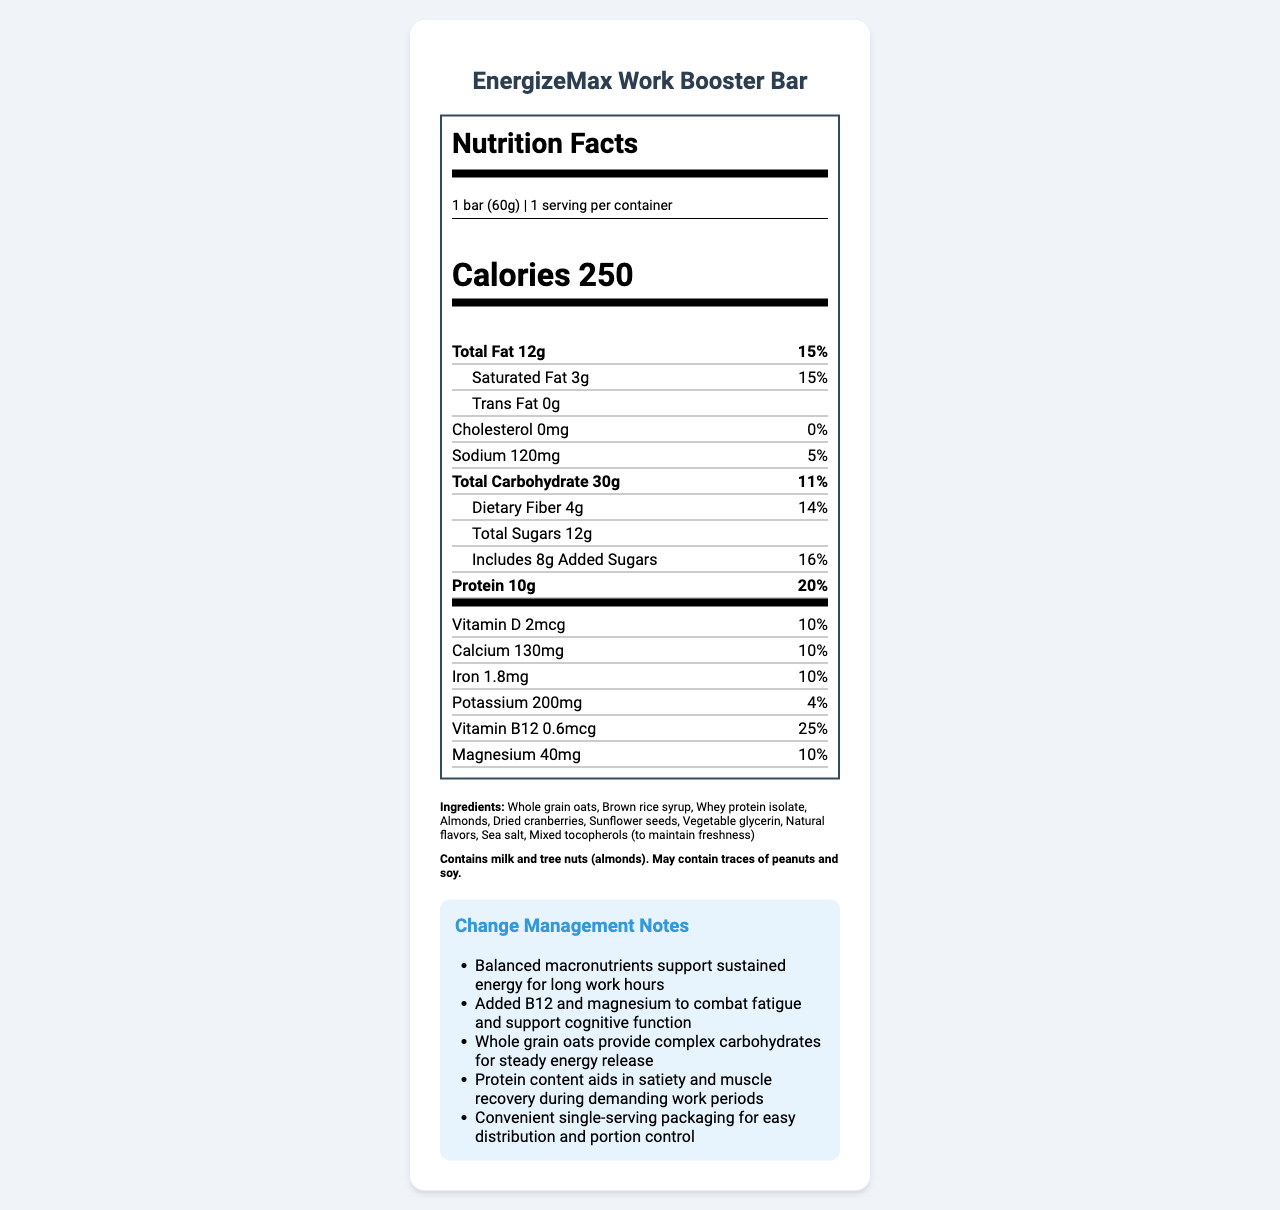what is the serving size of the EnergizeMax Work Booster Bar? The serving size information is directly mentioned as "1 bar (60g)" in the nutrition label.
Answer: 1 bar (60g) how many calories are in one serving of this snack bar? The document shows "Calories 250" in the nutrition label.
Answer: 250 what percentage of the daily value of protein does this bar provide? The protein section in the nutrition label indicates "Protein 10g" and shows "20%" for the percent daily value.
Answer: 20% does this snack contain any trans fats? The trans fat content is listed as "Trans Fat 0g" indicating that it contains no trans fats.
Answer: No what is the main benefit of the added B12 and magnesium according to the change management notes? The notes mention that added B12 and magnesium help combat fatigue and support cognitive function.
Answer: To combat fatigue and support cognitive function how much sodium is in this bar? The amount of sodium is listed in the nutrition label as "Sodium 120mg".
Answer: 120mg which vitamin has the highest percentage of the daily value? A. Vitamin D B. Calcium C. Vitamin B12 Vitamin B12 has a 25% daily value, which is the highest among the listed vitamins and minerals.
Answer: C. Vitamin B12 how many grams of total sugars does one serving contain? The nutrient section lists "Total Sugars 12g".
Answer: 12g how many grams of dietary fiber are in the bar? The nutritional label specifies "Dietary Fiber 4g".
Answer: 4g what are the primary ingredients in the EnergizeMax Work Booster Bar? A. Whole grain oats, Brown rice syrup, Whey protein isolate B. Whole grain oats, Dried cranberries, Sunflower seeds C. Whole grain oats, Natural flavors, Vegetable glycerin The ingredient list starts with "Whole grain oats, Brown rice syrup, Whey protein isolate" indicating these are the primary ingredients.
Answer: A. Whole grain oats, Brown rice syrup, Whey protein isolate does the bar contain any allergens? The allergen information states "Contains milk and tree nuts (almonds). May contain traces of peanuts and soy."
Answer: Yes what is the purpose of the single-serving packaging according to the change management notes? The notes highlight that convenient single-serving packaging is for easy distribution and portion control.
Answer: For easy distribution and portion control are there any artificial flavors listed in the ingredients? The ingredient list mentions "Natural flavors", specifying that no artificial flavors are included.
Answer: No are the sugars in the bar entirely natural? The nutrition label indicates that the bar includes "8g Added Sugars", meaning it contains some added sugars.
Answer: No provide a summary of the entire document This summary captures the key elements of the document, including nutritional content, ingredients, allergen information, and change management notes emphasizing benefits for long working hours.
Answer: The document describes the nutrition facts and change management notes for the EnergizeMax Work Booster Bar. Key nutritional elements include 250 calories per serving, 10g of protein, 12g of total sugars (8g of which are added sugars), and an array of vitamins and minerals such as Vitamin B12, Vitamin D, Calcium, Iron, Potassium, and Magnesium. The bar contains ingredients like whole grain oats, brown rice syrup, whey protein isolate, and almonds. Allergen information states it contains milk and tree nuts and may have traces of peanuts and soy. Change management notes emphasize balanced macronutrients for sustained energy, added B12 and magnesium to combat fatigue, complex carbs from oats for steady energy release, protein for satiety and muscle recovery, and convenient single-serving packaging for distribution and control. what is the shelf life of the EnergizeMax Work Booster Bar? The shelf life is not specified in the document, so the duration it remains consumable cannot be determined.
Answer: Not enough information 